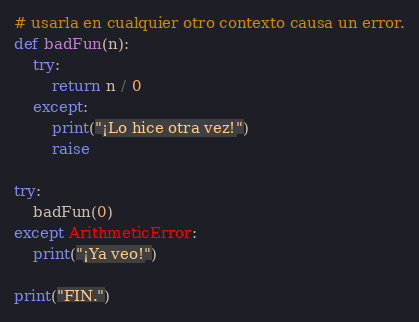<code> <loc_0><loc_0><loc_500><loc_500><_Python_># usarla en cualquier otro contexto causa un error.
def badFun(n):
    try:
        return n / 0
    except:
        print("¡Lo hice otra vez!")
        raise

try:
    badFun(0)
except ArithmeticError:
    print("¡Ya veo!")

print("FIN.")</code> 